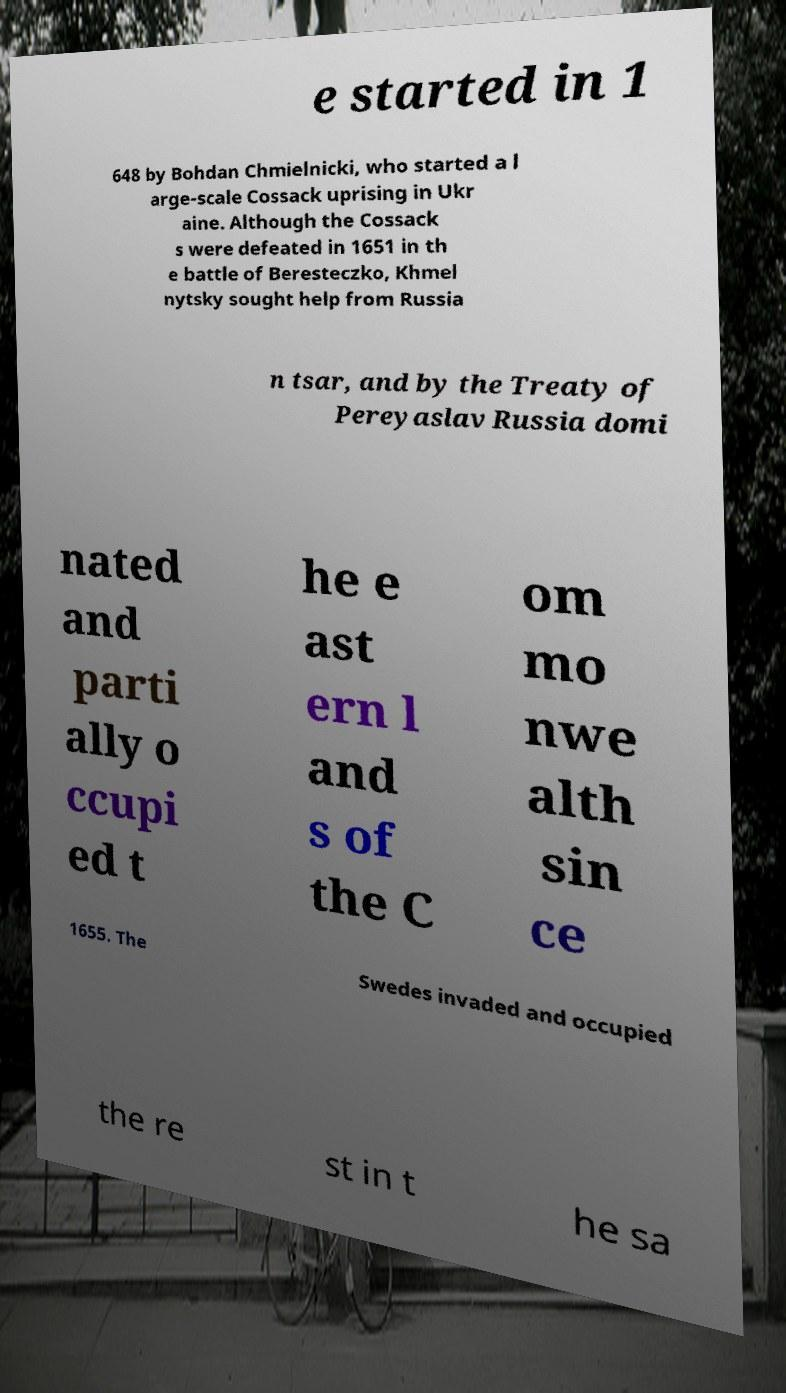What messages or text are displayed in this image? I need them in a readable, typed format. e started in 1 648 by Bohdan Chmielnicki, who started a l arge-scale Cossack uprising in Ukr aine. Although the Cossack s were defeated in 1651 in th e battle of Beresteczko, Khmel nytsky sought help from Russia n tsar, and by the Treaty of Pereyaslav Russia domi nated and parti ally o ccupi ed t he e ast ern l and s of the C om mo nwe alth sin ce 1655. The Swedes invaded and occupied the re st in t he sa 